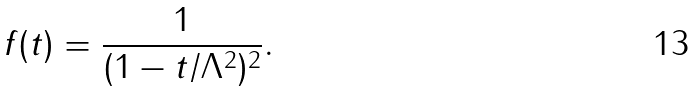Convert formula to latex. <formula><loc_0><loc_0><loc_500><loc_500>f ( t ) = \frac { 1 } { ( 1 - t / \Lambda ^ { 2 } ) ^ { 2 } } .</formula> 